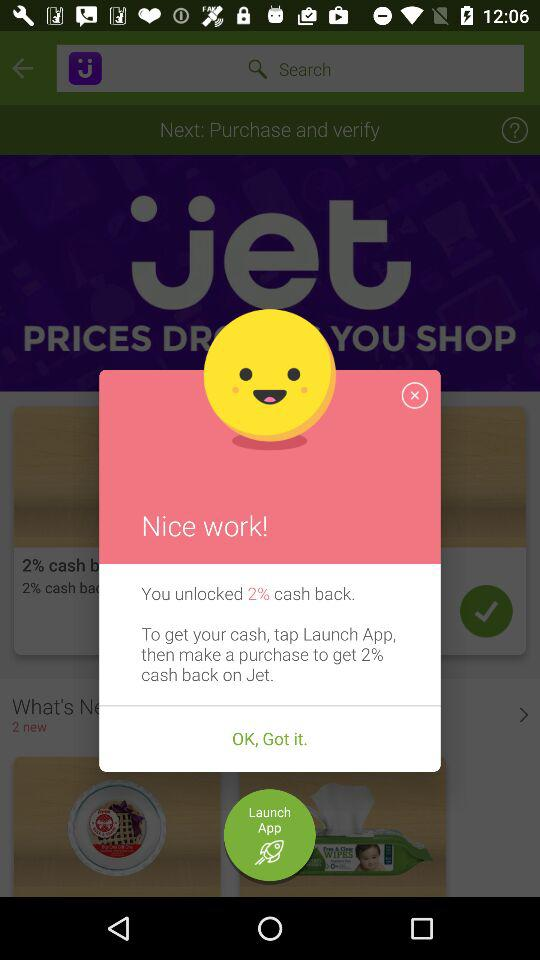What's the percentage of unlocked cash back? The percentage of unlocked cash back is 2. 